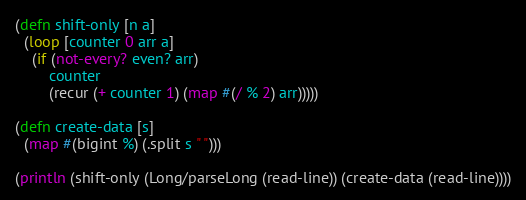<code> <loc_0><loc_0><loc_500><loc_500><_Clojure_>(defn shift-only [n a]
  (loop [counter 0 arr a]
    (if (not-every? even? arr)
        counter
        (recur (+ counter 1) (map #(/ % 2) arr)))))

(defn create-data [s]
  (map #(bigint %) (.split s " ")))

(println (shift-only (Long/parseLong (read-line)) (create-data (read-line))))</code> 